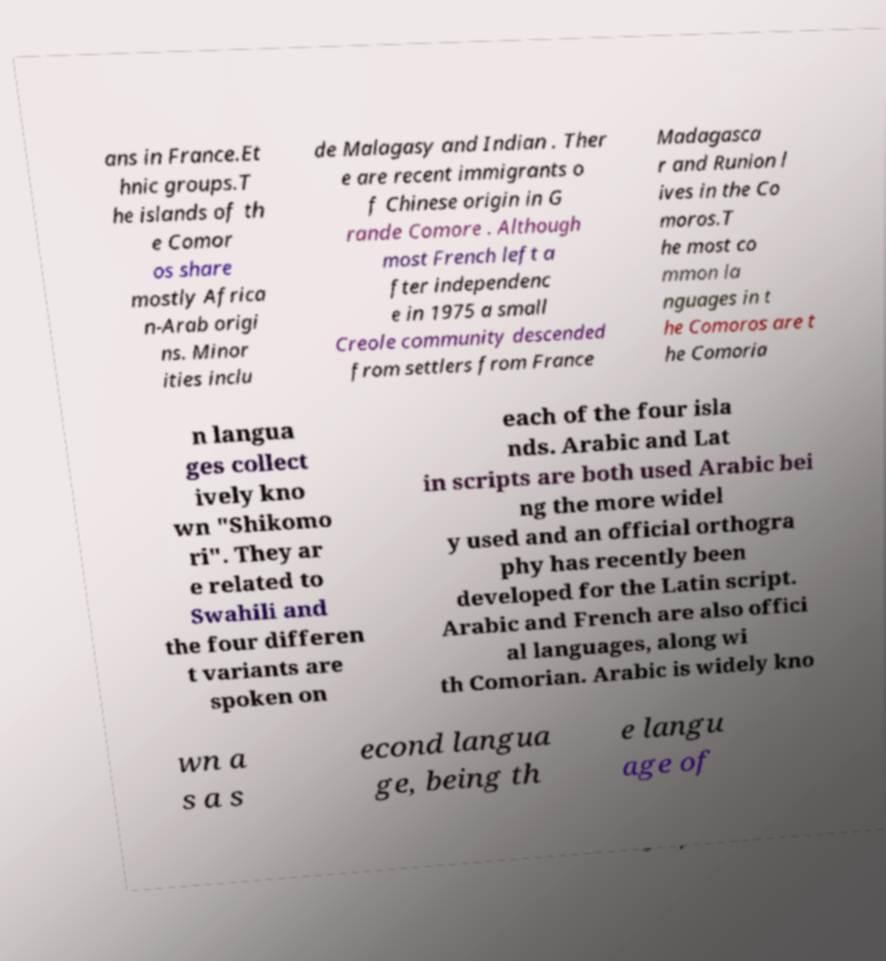I need the written content from this picture converted into text. Can you do that? ans in France.Et hnic groups.T he islands of th e Comor os share mostly Africa n-Arab origi ns. Minor ities inclu de Malagasy and Indian . Ther e are recent immigrants o f Chinese origin in G rande Comore . Although most French left a fter independenc e in 1975 a small Creole community descended from settlers from France Madagasca r and Runion l ives in the Co moros.T he most co mmon la nguages in t he Comoros are t he Comoria n langua ges collect ively kno wn "Shikomo ri". They ar e related to Swahili and the four differen t variants are spoken on each of the four isla nds. Arabic and Lat in scripts are both used Arabic bei ng the more widel y used and an official orthogra phy has recently been developed for the Latin script. Arabic and French are also offici al languages, along wi th Comorian. Arabic is widely kno wn a s a s econd langua ge, being th e langu age of 